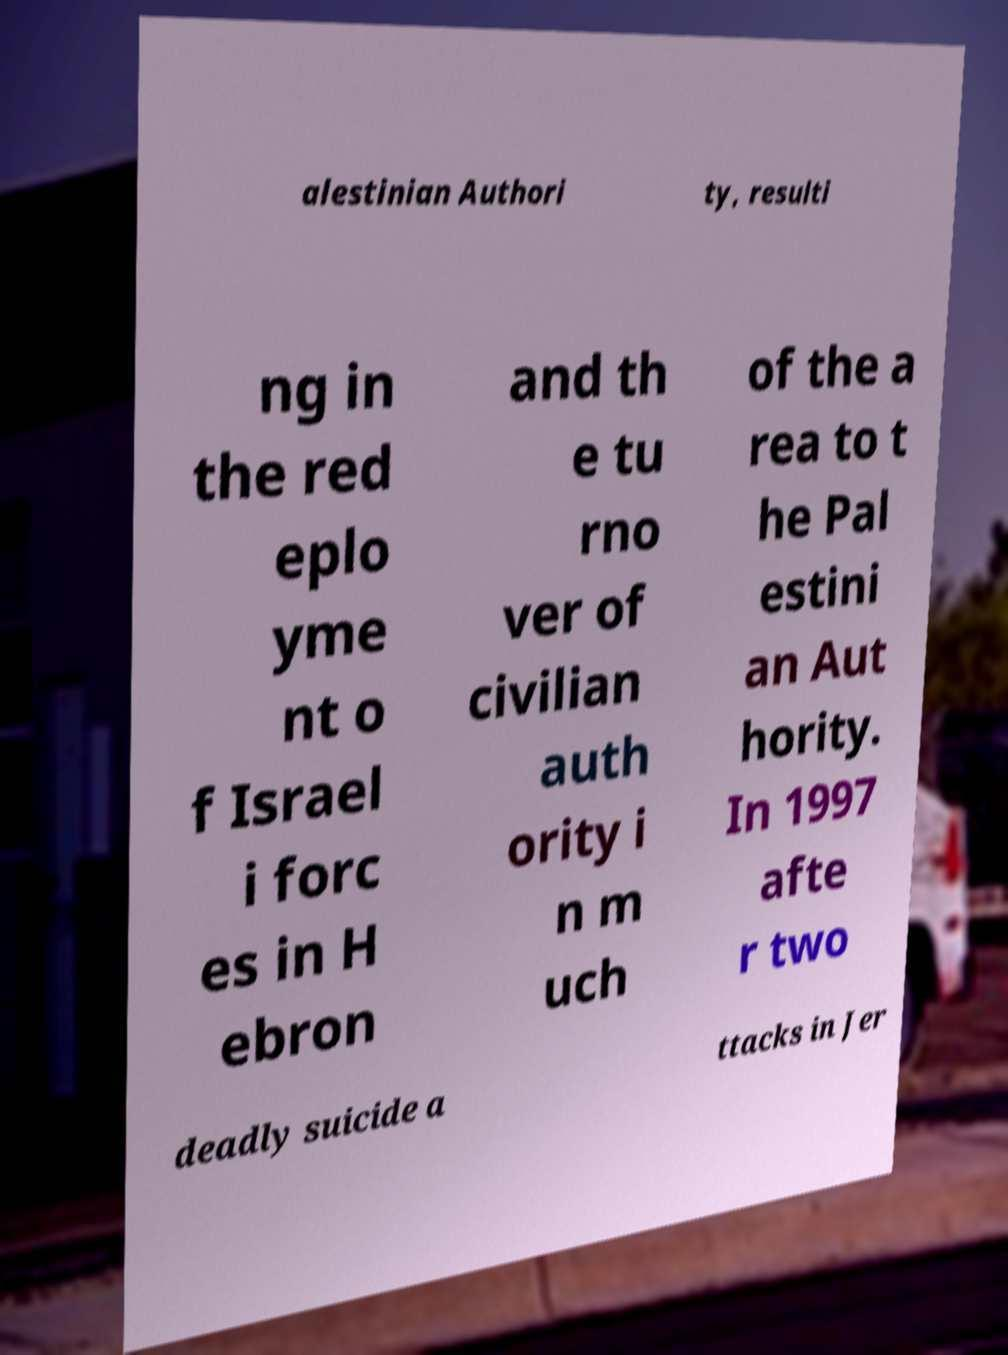Please identify and transcribe the text found in this image. alestinian Authori ty, resulti ng in the red eplo yme nt o f Israel i forc es in H ebron and th e tu rno ver of civilian auth ority i n m uch of the a rea to t he Pal estini an Aut hority. In 1997 afte r two deadly suicide a ttacks in Jer 